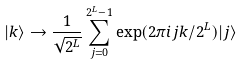Convert formula to latex. <formula><loc_0><loc_0><loc_500><loc_500>| k \rangle \rightarrow \frac { 1 } { \sqrt { 2 ^ { L } } } \sum _ { j = 0 } ^ { 2 ^ { L } - 1 } \exp ( 2 \pi i j k / 2 ^ { L } ) | j \rangle</formula> 